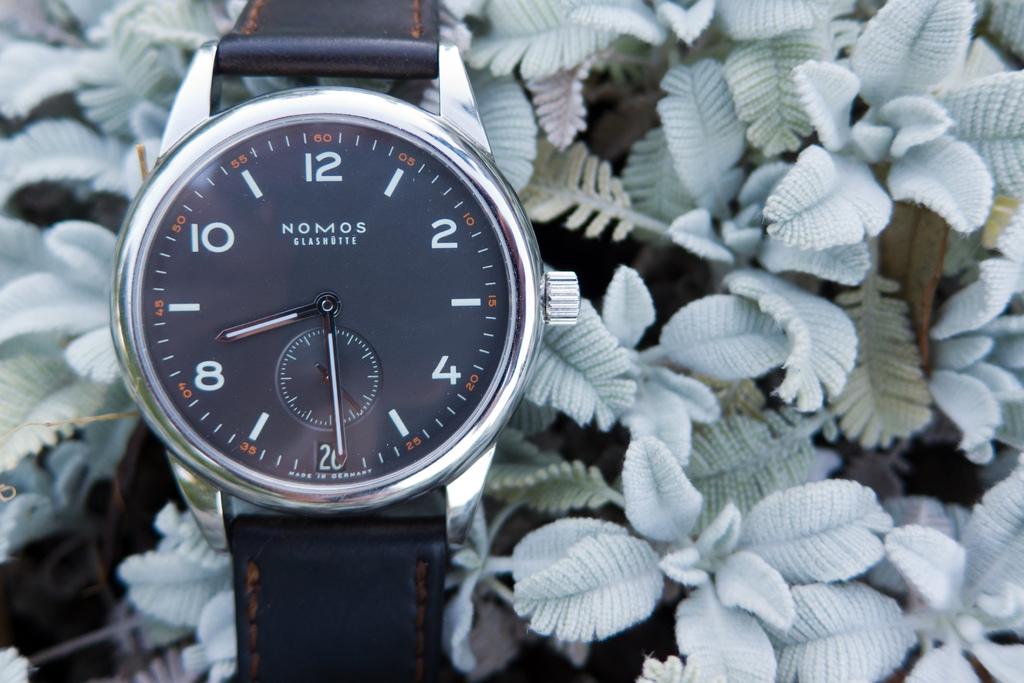What is the time on the watch?
Offer a terse response. 8:29. What brand of watch is this?
Make the answer very short. Nomos. 